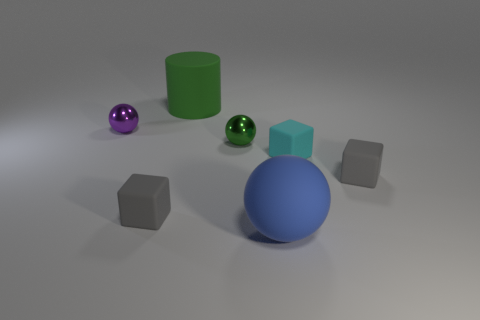What size is the metallic object that is the same color as the matte cylinder?
Provide a succinct answer. Small. There is a big cylinder; is it the same color as the small ball that is in front of the purple shiny thing?
Provide a succinct answer. Yes. How many big spheres have the same material as the purple object?
Your answer should be compact. 0. What color is the big cylinder?
Give a very brief answer. Green. Are there any large objects in front of the small green ball?
Give a very brief answer. Yes. How many small things are the same color as the big rubber cylinder?
Your answer should be compact. 1. There is a metallic sphere that is right of the small metallic object that is left of the large matte cylinder; what is its size?
Your response must be concise. Small. What is the shape of the large blue thing?
Provide a short and direct response. Sphere. What material is the cube that is on the right side of the tiny cyan block?
Provide a short and direct response. Rubber. There is a small shiny object right of the small gray matte thing on the left side of the big object in front of the small green metallic sphere; what is its color?
Your response must be concise. Green. 